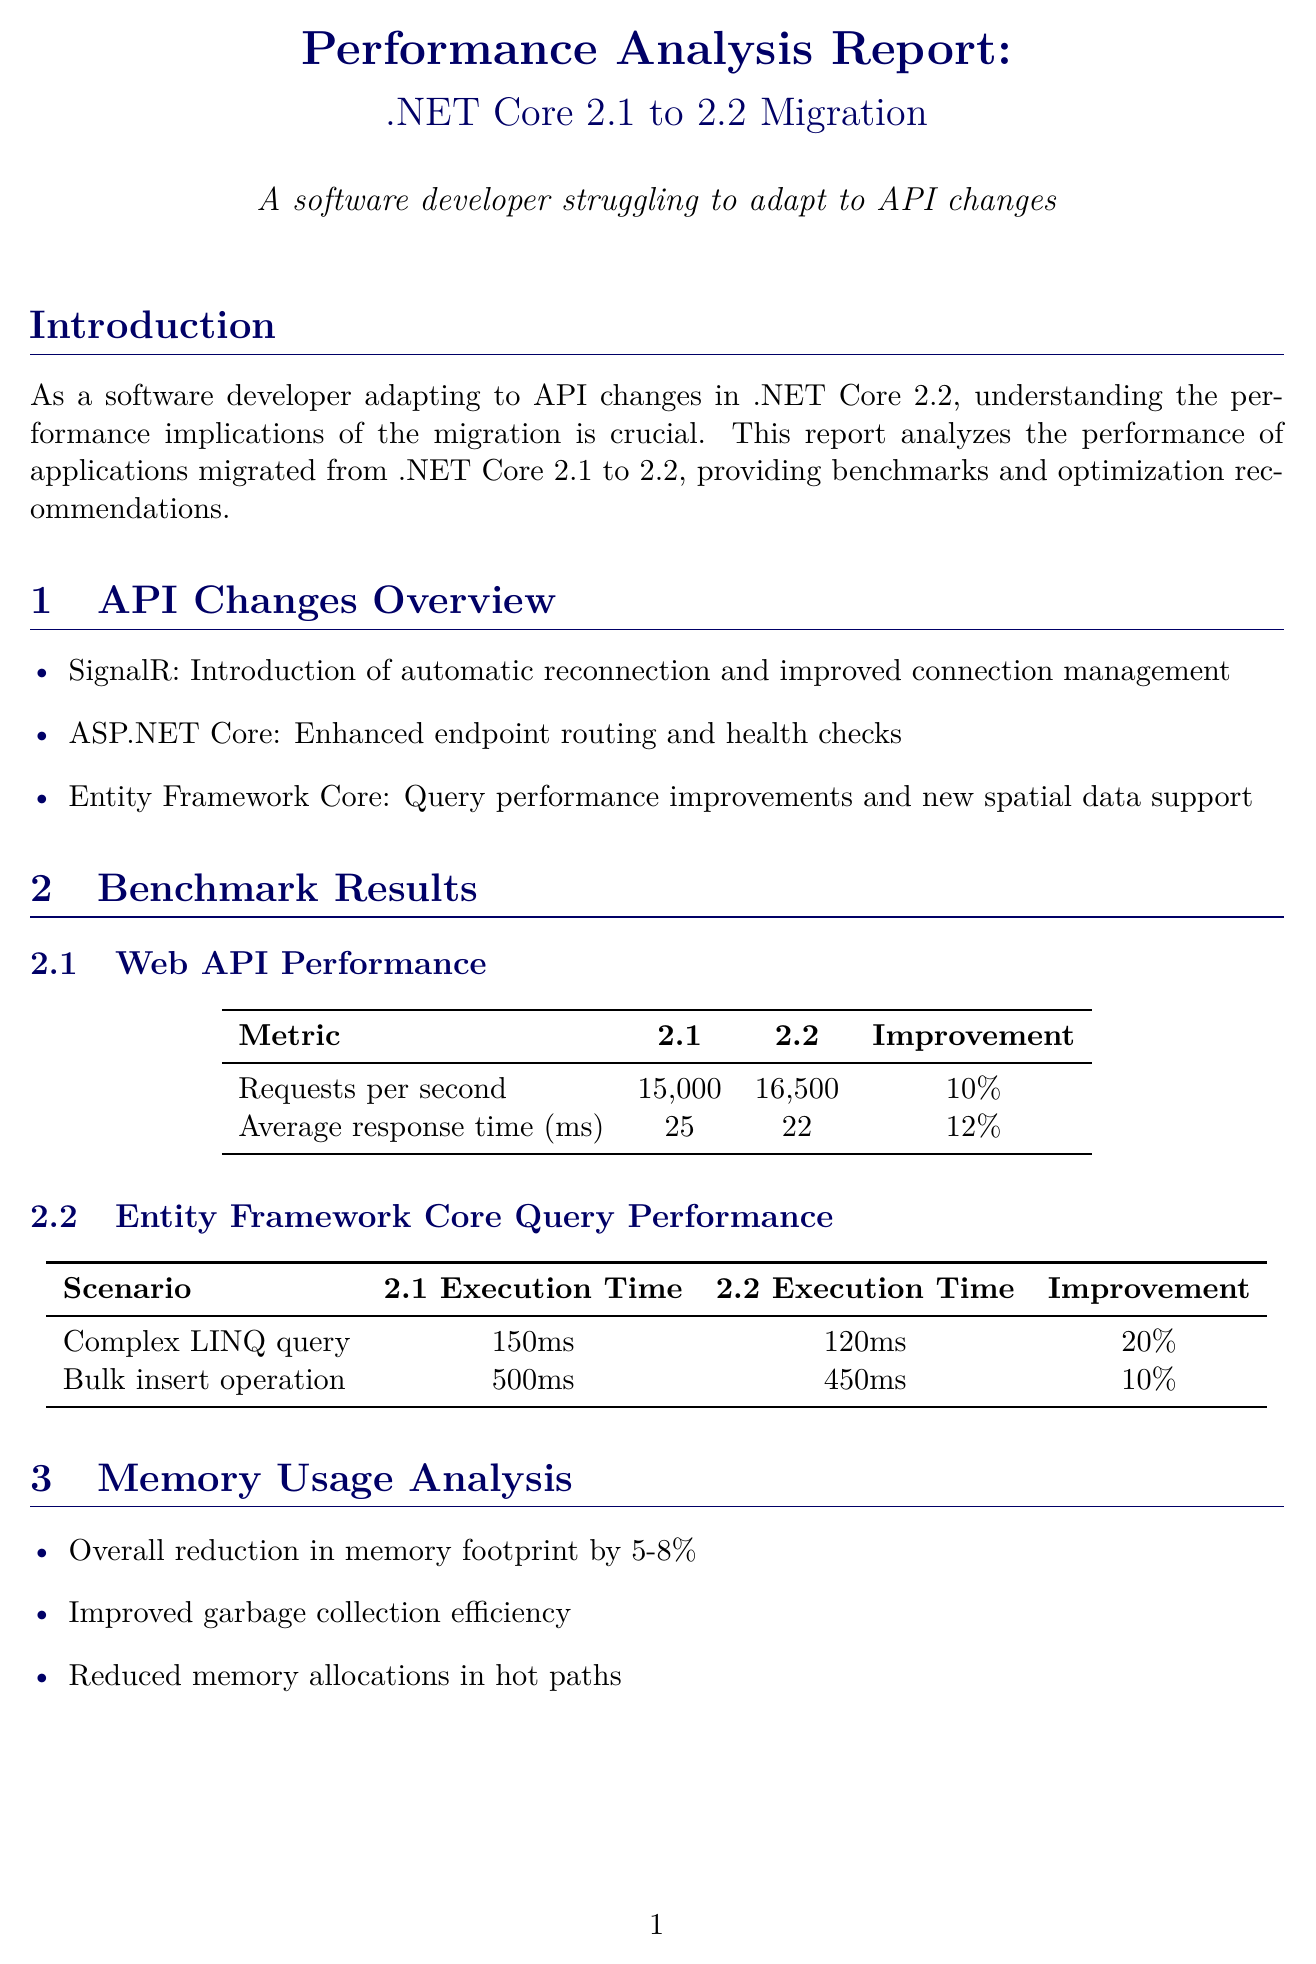what is the performance improvement for requests per second from 2.1 to 2.2? The report states that requests per second improved from 15,000 in 2.1 to 16,500 in 2.2, which is a 10% improvement.
Answer: 10% what is one new feature introduced in SignalR? The report mentions that one new feature is automatic reconnection and improved connection management.
Answer: automatic reconnection what is the execution time for a complex LINQ query in .NET Core 2.2? According to the benchmark results, the execution time for a complex LINQ query in 2.2 is 120 milliseconds.
Answer: 120ms how much was the average page load time reduced for the ShopNow case study? The case study on ShopNow shows a 20% reduction in average page load time.
Answer: 20% what is a recommended optimization for database interactions? The report suggests reviewing and optimizing LINQ queries to benefit from EF Core improvements.
Answer: review and optimize LINQ queries what issue is associated with breaking changes in SignalR client? The issue identified is the need to update client libraries and refactor connection management code.
Answer: update client libraries what percentage increase in concurrent user capacity does the e-commerce platform ShopNow achieve? The report states a 15% increase in concurrent user capacity for ShopNow.
Answer: 15% name one tool recommended for performance analysis. The report lists dotnet-trace as a command-line tool for collecting runtime performance traces.
Answer: dotnet-trace 